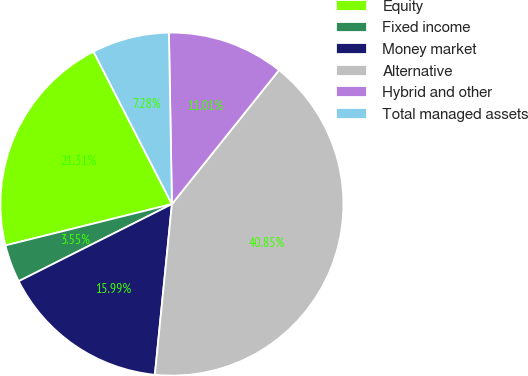<chart> <loc_0><loc_0><loc_500><loc_500><pie_chart><fcel>Equity<fcel>Fixed income<fcel>Money market<fcel>Alternative<fcel>Hybrid and other<fcel>Total managed assets<nl><fcel>21.31%<fcel>3.55%<fcel>15.99%<fcel>40.85%<fcel>11.01%<fcel>7.28%<nl></chart> 